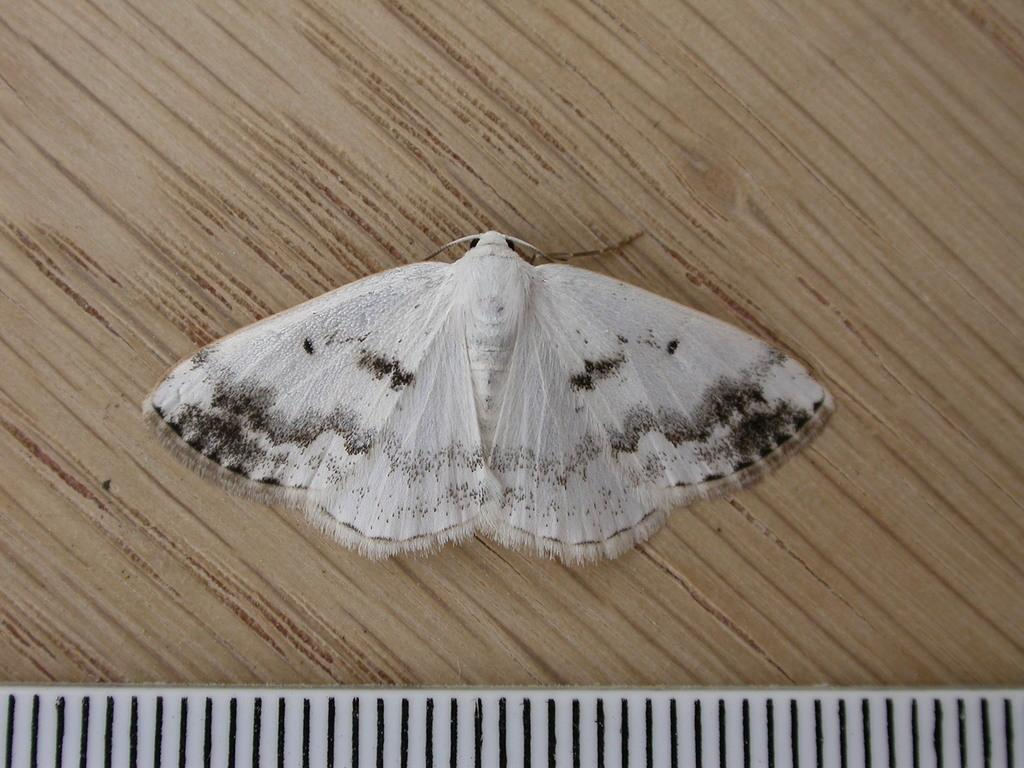What is the main subject of the image? There is a butterfly in the image. What is the butterfly resting on in the image? The butterfly is on a wooden surface. What type of authority does the butterfly have in the image? There is no indication of authority in the image, as it features a butterfly on a wooden surface. Is the butterfly a spy in the image? There is no indication of the butterfly being a spy in the image; it is simply resting on a wooden surface. 